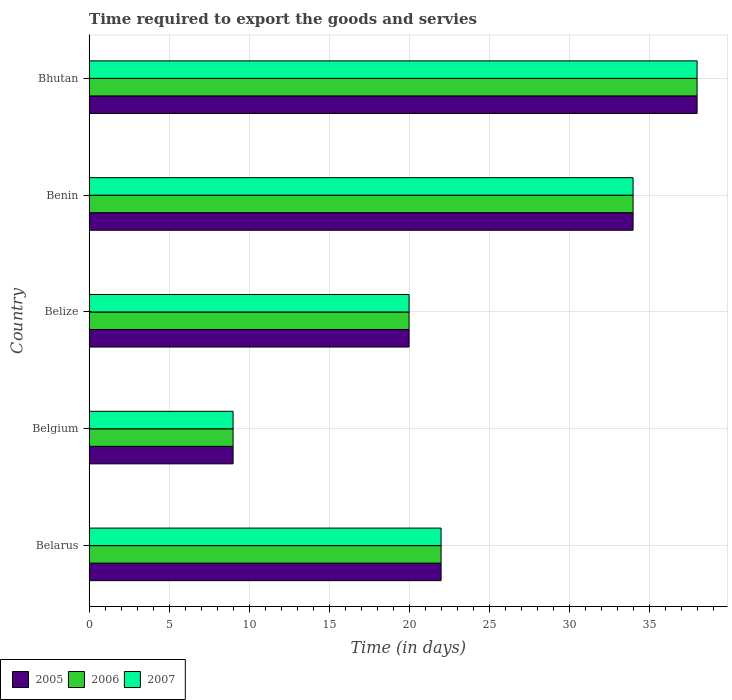How many different coloured bars are there?
Your answer should be very brief. 3. Are the number of bars per tick equal to the number of legend labels?
Your answer should be compact. Yes. How many bars are there on the 1st tick from the top?
Your answer should be compact. 3. How many bars are there on the 3rd tick from the bottom?
Provide a short and direct response. 3. What is the label of the 2nd group of bars from the top?
Your answer should be compact. Benin. In how many cases, is the number of bars for a given country not equal to the number of legend labels?
Your answer should be compact. 0. What is the number of days required to export the goods and services in 2005 in Benin?
Make the answer very short. 34. Across all countries, what is the minimum number of days required to export the goods and services in 2006?
Offer a terse response. 9. In which country was the number of days required to export the goods and services in 2005 maximum?
Keep it short and to the point. Bhutan. What is the total number of days required to export the goods and services in 2006 in the graph?
Offer a very short reply. 123. What is the difference between the number of days required to export the goods and services in 2005 in Belarus and that in Bhutan?
Give a very brief answer. -16. What is the average number of days required to export the goods and services in 2006 per country?
Provide a short and direct response. 24.6. What is the ratio of the number of days required to export the goods and services in 2006 in Belarus to that in Benin?
Ensure brevity in your answer.  0.65. Is the number of days required to export the goods and services in 2006 in Belgium less than that in Benin?
Make the answer very short. Yes. In how many countries, is the number of days required to export the goods and services in 2005 greater than the average number of days required to export the goods and services in 2005 taken over all countries?
Provide a succinct answer. 2. Is the sum of the number of days required to export the goods and services in 2005 in Belize and Bhutan greater than the maximum number of days required to export the goods and services in 2007 across all countries?
Give a very brief answer. Yes. How many countries are there in the graph?
Provide a succinct answer. 5. Does the graph contain grids?
Provide a short and direct response. Yes. How many legend labels are there?
Offer a very short reply. 3. How are the legend labels stacked?
Keep it short and to the point. Horizontal. What is the title of the graph?
Make the answer very short. Time required to export the goods and servies. What is the label or title of the X-axis?
Ensure brevity in your answer.  Time (in days). What is the label or title of the Y-axis?
Your answer should be compact. Country. What is the Time (in days) of 2005 in Belarus?
Offer a very short reply. 22. What is the Time (in days) of 2007 in Belarus?
Offer a very short reply. 22. What is the Time (in days) of 2005 in Belgium?
Offer a terse response. 9. What is the Time (in days) of 2006 in Belgium?
Provide a short and direct response. 9. What is the Time (in days) in 2007 in Belgium?
Give a very brief answer. 9. What is the Time (in days) in 2006 in Benin?
Provide a short and direct response. 34. What is the Time (in days) of 2007 in Benin?
Your answer should be compact. 34. Across all countries, what is the maximum Time (in days) in 2005?
Ensure brevity in your answer.  38. Across all countries, what is the maximum Time (in days) in 2006?
Offer a terse response. 38. Across all countries, what is the maximum Time (in days) of 2007?
Make the answer very short. 38. What is the total Time (in days) in 2005 in the graph?
Your answer should be very brief. 123. What is the total Time (in days) in 2006 in the graph?
Your answer should be very brief. 123. What is the total Time (in days) of 2007 in the graph?
Give a very brief answer. 123. What is the difference between the Time (in days) in 2005 in Belarus and that in Belgium?
Offer a terse response. 13. What is the difference between the Time (in days) in 2006 in Belarus and that in Belgium?
Provide a succinct answer. 13. What is the difference between the Time (in days) of 2007 in Belarus and that in Belgium?
Keep it short and to the point. 13. What is the difference between the Time (in days) in 2007 in Belarus and that in Belize?
Make the answer very short. 2. What is the difference between the Time (in days) in 2007 in Belarus and that in Bhutan?
Provide a short and direct response. -16. What is the difference between the Time (in days) of 2007 in Belgium and that in Belize?
Provide a short and direct response. -11. What is the difference between the Time (in days) of 2007 in Belgium and that in Benin?
Provide a short and direct response. -25. What is the difference between the Time (in days) of 2006 in Belgium and that in Bhutan?
Give a very brief answer. -29. What is the difference between the Time (in days) of 2007 in Belgium and that in Bhutan?
Keep it short and to the point. -29. What is the difference between the Time (in days) in 2005 in Belize and that in Benin?
Ensure brevity in your answer.  -14. What is the difference between the Time (in days) of 2006 in Belize and that in Bhutan?
Your answer should be very brief. -18. What is the difference between the Time (in days) of 2006 in Benin and that in Bhutan?
Give a very brief answer. -4. What is the difference between the Time (in days) in 2006 in Belarus and the Time (in days) in 2007 in Belgium?
Offer a terse response. 13. What is the difference between the Time (in days) of 2006 in Belarus and the Time (in days) of 2007 in Belize?
Make the answer very short. 2. What is the difference between the Time (in days) of 2005 in Belarus and the Time (in days) of 2006 in Benin?
Ensure brevity in your answer.  -12. What is the difference between the Time (in days) of 2005 in Belarus and the Time (in days) of 2007 in Benin?
Provide a succinct answer. -12. What is the difference between the Time (in days) of 2006 in Belarus and the Time (in days) of 2007 in Benin?
Your response must be concise. -12. What is the difference between the Time (in days) of 2005 in Belarus and the Time (in days) of 2006 in Bhutan?
Provide a short and direct response. -16. What is the difference between the Time (in days) of 2006 in Belarus and the Time (in days) of 2007 in Bhutan?
Keep it short and to the point. -16. What is the difference between the Time (in days) in 2005 in Belgium and the Time (in days) in 2006 in Belize?
Ensure brevity in your answer.  -11. What is the difference between the Time (in days) of 2006 in Belgium and the Time (in days) of 2007 in Belize?
Ensure brevity in your answer.  -11. What is the difference between the Time (in days) of 2005 in Belgium and the Time (in days) of 2006 in Benin?
Your answer should be very brief. -25. What is the difference between the Time (in days) of 2005 in Belgium and the Time (in days) of 2007 in Benin?
Give a very brief answer. -25. What is the difference between the Time (in days) of 2006 in Belgium and the Time (in days) of 2007 in Benin?
Your answer should be very brief. -25. What is the difference between the Time (in days) of 2006 in Belgium and the Time (in days) of 2007 in Bhutan?
Provide a short and direct response. -29. What is the difference between the Time (in days) of 2005 in Belize and the Time (in days) of 2006 in Benin?
Your response must be concise. -14. What is the difference between the Time (in days) of 2005 in Belize and the Time (in days) of 2007 in Benin?
Offer a terse response. -14. What is the difference between the Time (in days) of 2006 in Belize and the Time (in days) of 2007 in Benin?
Your answer should be compact. -14. What is the difference between the Time (in days) in 2005 in Benin and the Time (in days) in 2006 in Bhutan?
Offer a terse response. -4. What is the difference between the Time (in days) of 2006 in Benin and the Time (in days) of 2007 in Bhutan?
Your response must be concise. -4. What is the average Time (in days) of 2005 per country?
Ensure brevity in your answer.  24.6. What is the average Time (in days) in 2006 per country?
Your answer should be compact. 24.6. What is the average Time (in days) in 2007 per country?
Your response must be concise. 24.6. What is the difference between the Time (in days) of 2005 and Time (in days) of 2006 in Belarus?
Keep it short and to the point. 0. What is the difference between the Time (in days) in 2005 and Time (in days) in 2007 in Belarus?
Offer a very short reply. 0. What is the difference between the Time (in days) in 2006 and Time (in days) in 2007 in Belarus?
Provide a succinct answer. 0. What is the difference between the Time (in days) of 2005 and Time (in days) of 2006 in Belgium?
Make the answer very short. 0. What is the difference between the Time (in days) of 2005 and Time (in days) of 2007 in Belgium?
Provide a succinct answer. 0. What is the difference between the Time (in days) of 2006 and Time (in days) of 2007 in Belgium?
Give a very brief answer. 0. What is the difference between the Time (in days) in 2006 and Time (in days) in 2007 in Belize?
Offer a terse response. 0. What is the difference between the Time (in days) in 2005 and Time (in days) in 2006 in Benin?
Provide a succinct answer. 0. What is the difference between the Time (in days) of 2005 and Time (in days) of 2007 in Benin?
Give a very brief answer. 0. What is the difference between the Time (in days) in 2006 and Time (in days) in 2007 in Benin?
Keep it short and to the point. 0. What is the difference between the Time (in days) in 2005 and Time (in days) in 2006 in Bhutan?
Offer a very short reply. 0. What is the difference between the Time (in days) in 2005 and Time (in days) in 2007 in Bhutan?
Ensure brevity in your answer.  0. What is the difference between the Time (in days) of 2006 and Time (in days) of 2007 in Bhutan?
Your answer should be very brief. 0. What is the ratio of the Time (in days) in 2005 in Belarus to that in Belgium?
Your response must be concise. 2.44. What is the ratio of the Time (in days) in 2006 in Belarus to that in Belgium?
Offer a terse response. 2.44. What is the ratio of the Time (in days) in 2007 in Belarus to that in Belgium?
Provide a succinct answer. 2.44. What is the ratio of the Time (in days) of 2006 in Belarus to that in Belize?
Your answer should be compact. 1.1. What is the ratio of the Time (in days) of 2007 in Belarus to that in Belize?
Keep it short and to the point. 1.1. What is the ratio of the Time (in days) of 2005 in Belarus to that in Benin?
Ensure brevity in your answer.  0.65. What is the ratio of the Time (in days) in 2006 in Belarus to that in Benin?
Give a very brief answer. 0.65. What is the ratio of the Time (in days) of 2007 in Belarus to that in Benin?
Your answer should be compact. 0.65. What is the ratio of the Time (in days) in 2005 in Belarus to that in Bhutan?
Provide a succinct answer. 0.58. What is the ratio of the Time (in days) of 2006 in Belarus to that in Bhutan?
Keep it short and to the point. 0.58. What is the ratio of the Time (in days) in 2007 in Belarus to that in Bhutan?
Your response must be concise. 0.58. What is the ratio of the Time (in days) in 2005 in Belgium to that in Belize?
Offer a very short reply. 0.45. What is the ratio of the Time (in days) in 2006 in Belgium to that in Belize?
Your answer should be compact. 0.45. What is the ratio of the Time (in days) in 2007 in Belgium to that in Belize?
Your response must be concise. 0.45. What is the ratio of the Time (in days) of 2005 in Belgium to that in Benin?
Your answer should be very brief. 0.26. What is the ratio of the Time (in days) in 2006 in Belgium to that in Benin?
Your answer should be very brief. 0.26. What is the ratio of the Time (in days) in 2007 in Belgium to that in Benin?
Your response must be concise. 0.26. What is the ratio of the Time (in days) of 2005 in Belgium to that in Bhutan?
Your answer should be compact. 0.24. What is the ratio of the Time (in days) in 2006 in Belgium to that in Bhutan?
Make the answer very short. 0.24. What is the ratio of the Time (in days) in 2007 in Belgium to that in Bhutan?
Your response must be concise. 0.24. What is the ratio of the Time (in days) of 2005 in Belize to that in Benin?
Offer a very short reply. 0.59. What is the ratio of the Time (in days) of 2006 in Belize to that in Benin?
Provide a succinct answer. 0.59. What is the ratio of the Time (in days) of 2007 in Belize to that in Benin?
Offer a very short reply. 0.59. What is the ratio of the Time (in days) of 2005 in Belize to that in Bhutan?
Provide a succinct answer. 0.53. What is the ratio of the Time (in days) of 2006 in Belize to that in Bhutan?
Make the answer very short. 0.53. What is the ratio of the Time (in days) in 2007 in Belize to that in Bhutan?
Provide a short and direct response. 0.53. What is the ratio of the Time (in days) in 2005 in Benin to that in Bhutan?
Ensure brevity in your answer.  0.89. What is the ratio of the Time (in days) in 2006 in Benin to that in Bhutan?
Make the answer very short. 0.89. What is the ratio of the Time (in days) of 2007 in Benin to that in Bhutan?
Offer a terse response. 0.89. What is the difference between the highest and the second highest Time (in days) of 2005?
Your answer should be compact. 4. What is the difference between the highest and the second highest Time (in days) in 2006?
Your response must be concise. 4. What is the difference between the highest and the second highest Time (in days) of 2007?
Make the answer very short. 4. What is the difference between the highest and the lowest Time (in days) in 2005?
Make the answer very short. 29. What is the difference between the highest and the lowest Time (in days) in 2007?
Offer a very short reply. 29. 